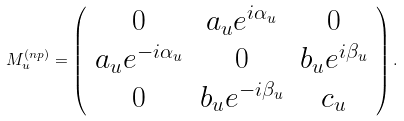Convert formula to latex. <formula><loc_0><loc_0><loc_500><loc_500>M _ { u } ^ { ( n p ) } = \left ( \begin{array} { c c c } 0 & a _ { u } e ^ { i \alpha _ { u } } & 0 \\ a _ { u } e ^ { - i \alpha _ { u } } & 0 & b _ { u } e ^ { i \beta _ { u } } \\ 0 & b _ { u } e ^ { - i \beta _ { u } } & c _ { u } \end{array} \right ) .</formula> 